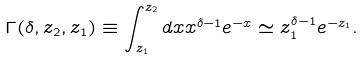<formula> <loc_0><loc_0><loc_500><loc_500>\Gamma ( \delta , z _ { 2 } , z _ { 1 } ) \equiv \int _ { z _ { 1 } } ^ { z _ { 2 } } d x x ^ { \delta - 1 } e ^ { - x } \simeq z _ { 1 } ^ { \delta - 1 } e ^ { - z _ { 1 } } .</formula> 